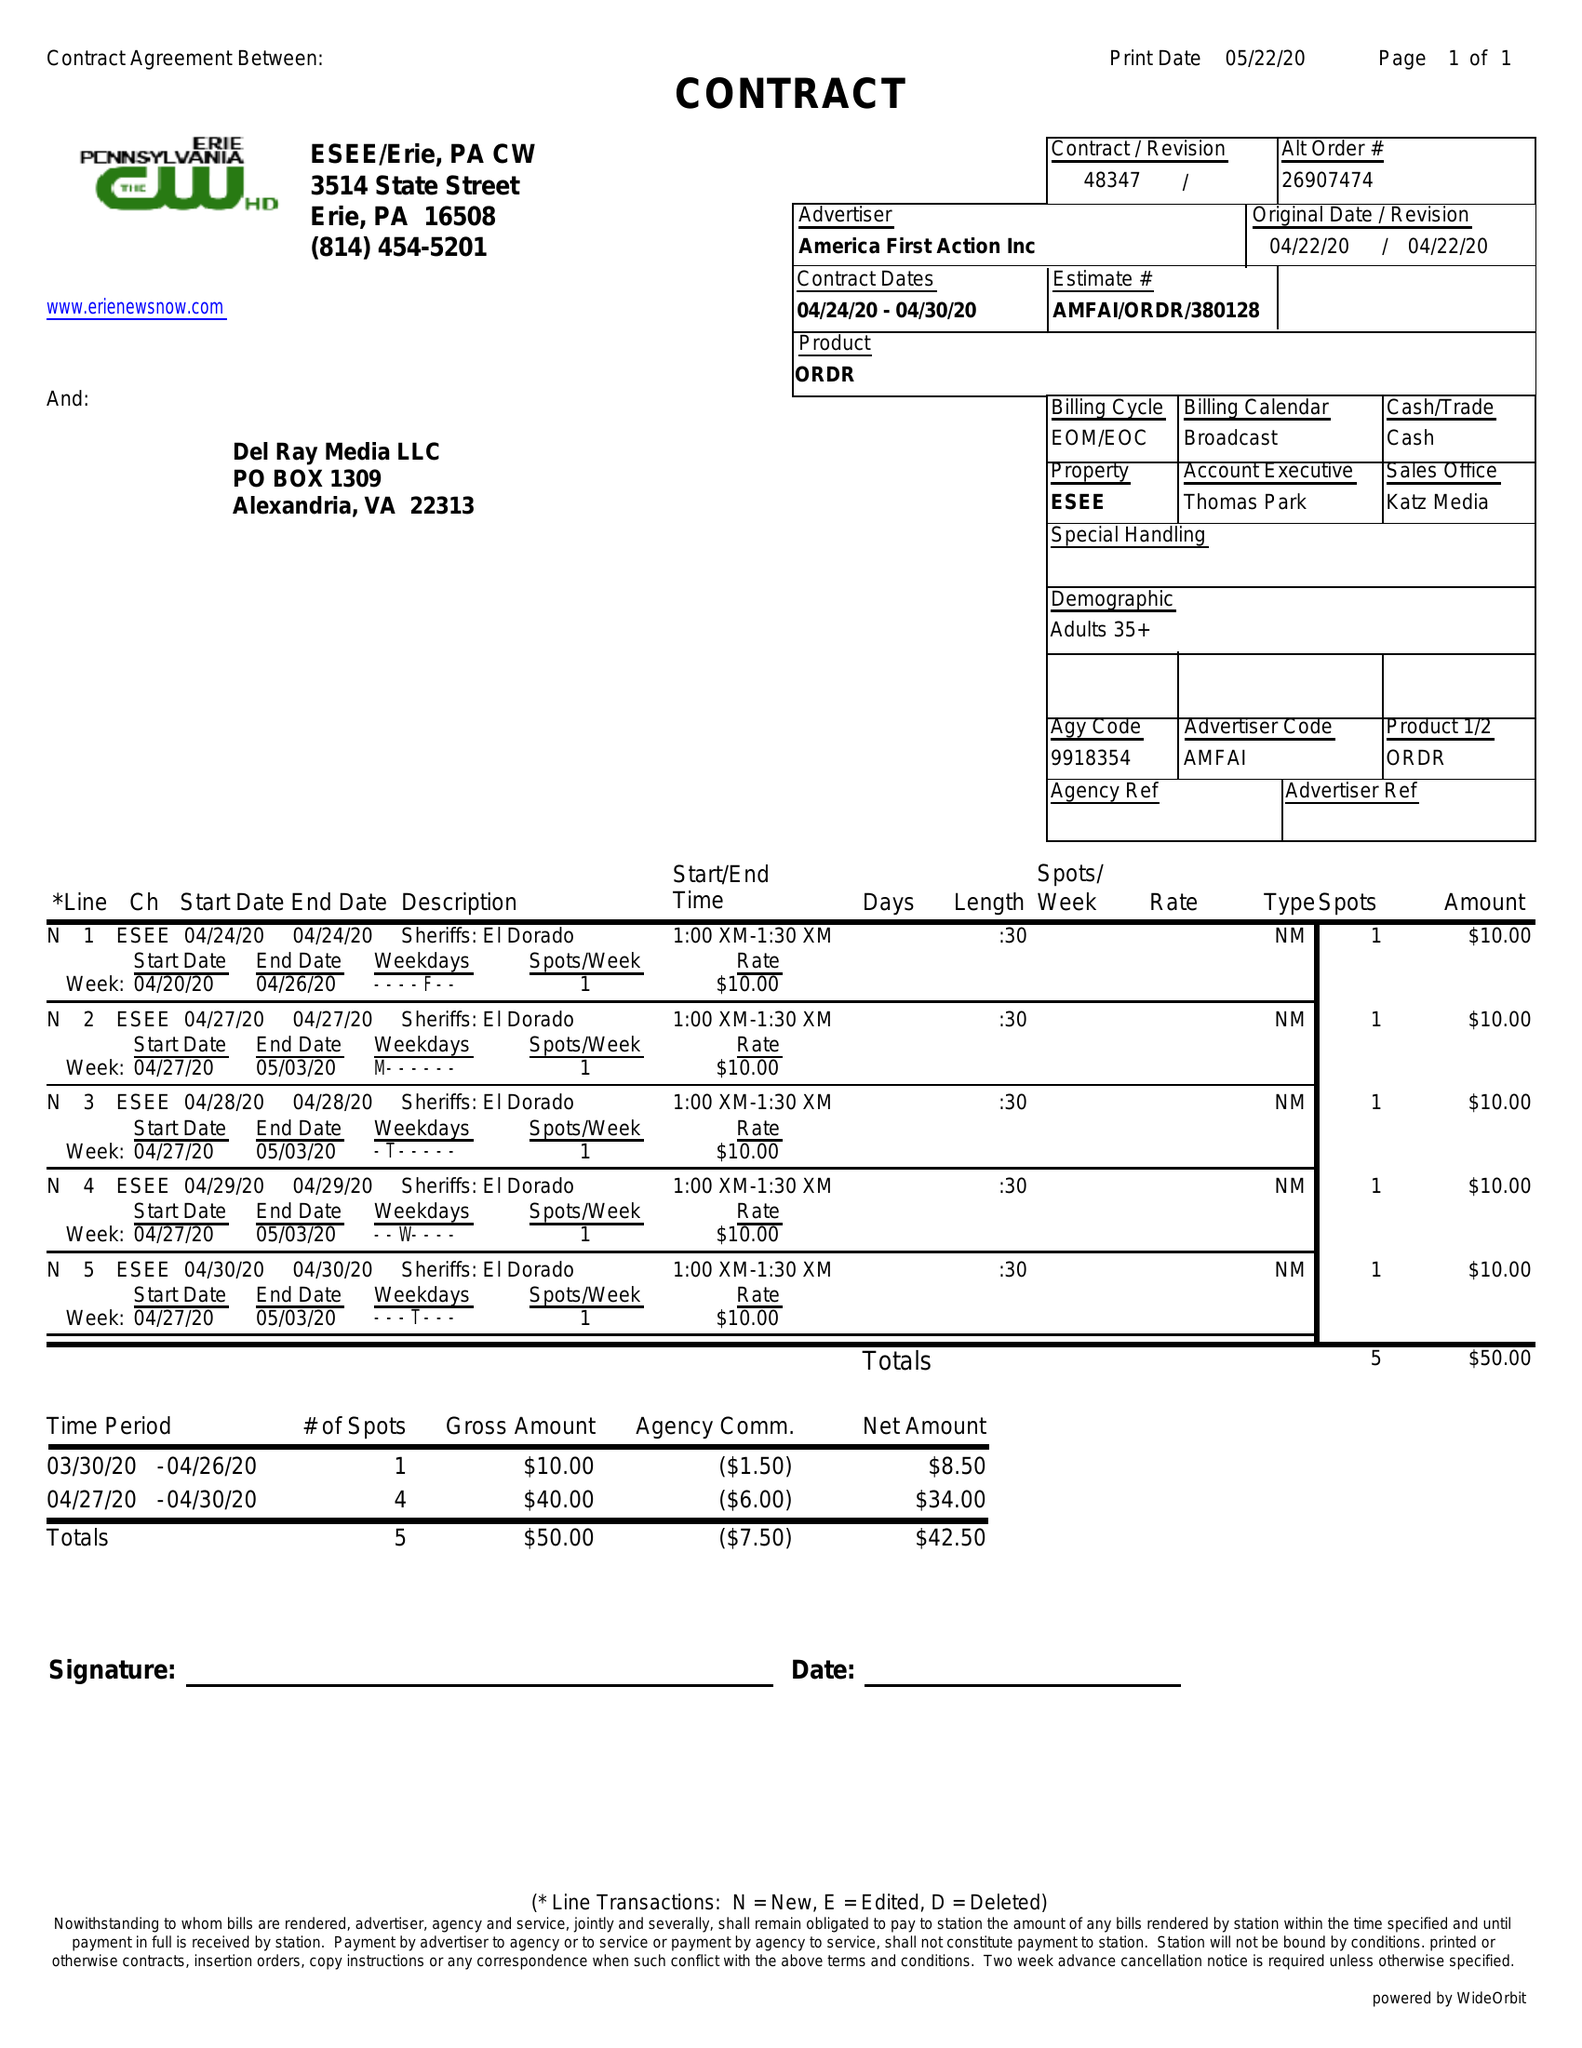What is the value for the contract_num?
Answer the question using a single word or phrase. 48347 